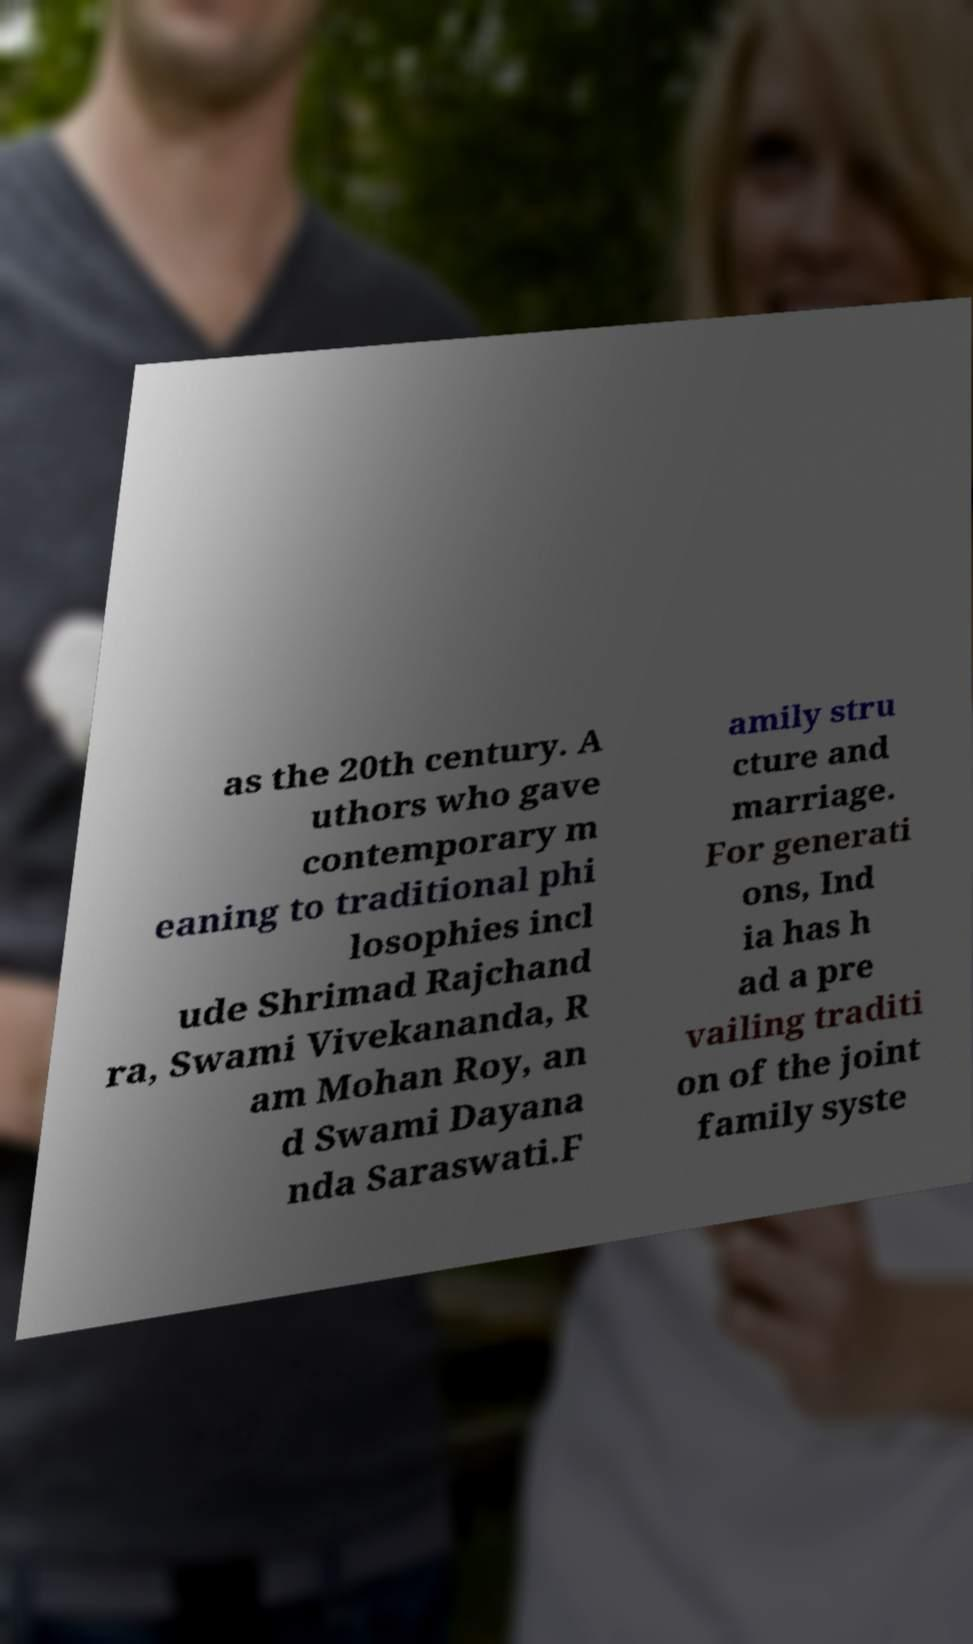Please read and relay the text visible in this image. What does it say? as the 20th century. A uthors who gave contemporary m eaning to traditional phi losophies incl ude Shrimad Rajchand ra, Swami Vivekananda, R am Mohan Roy, an d Swami Dayana nda Saraswati.F amily stru cture and marriage. For generati ons, Ind ia has h ad a pre vailing traditi on of the joint family syste 